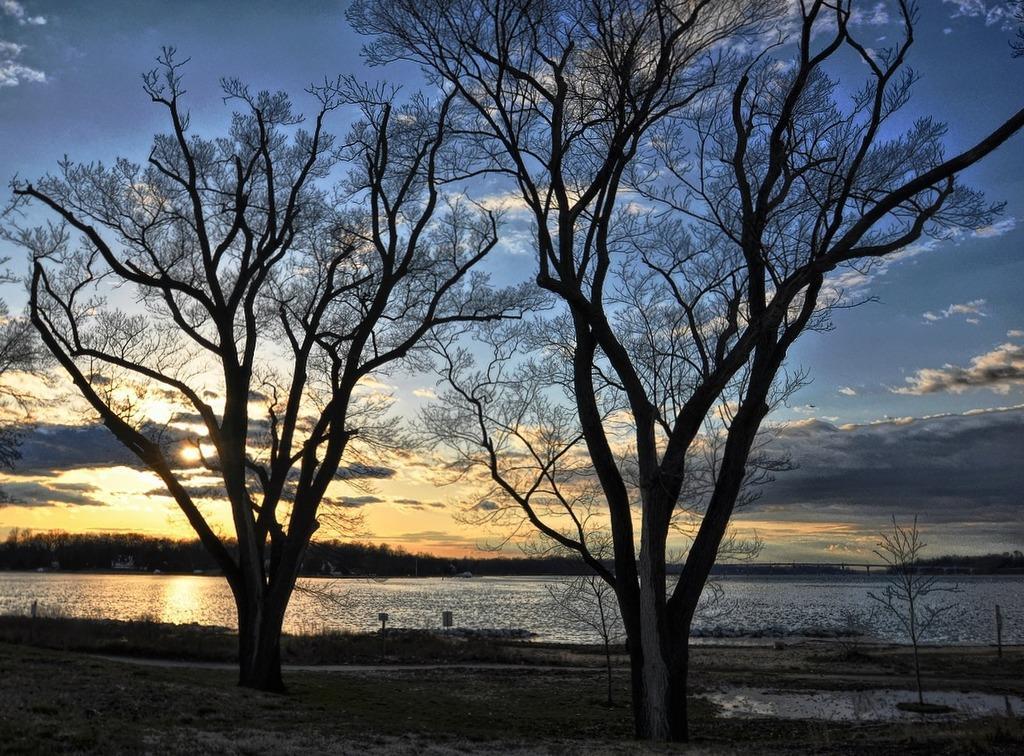Could you give a brief overview of what you see in this image? In this image I can see few trees, background I can see the water and the sky is in blue and white color. 